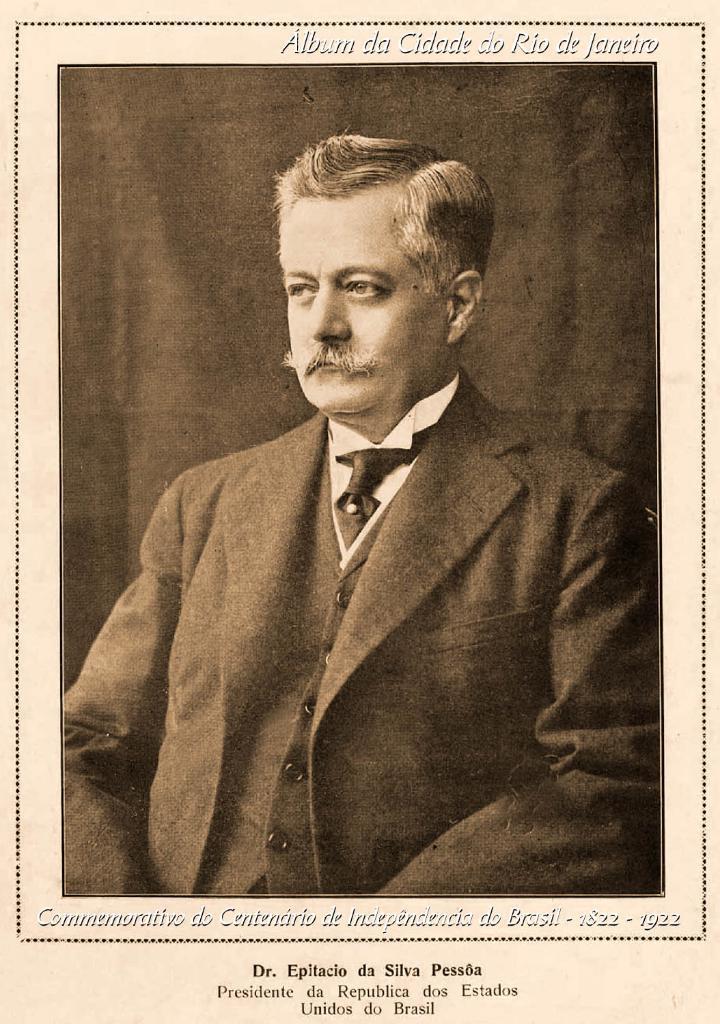Can you describe this image briefly? In this image I can see person. He is wearing coat and tie. The image is in black and white. 